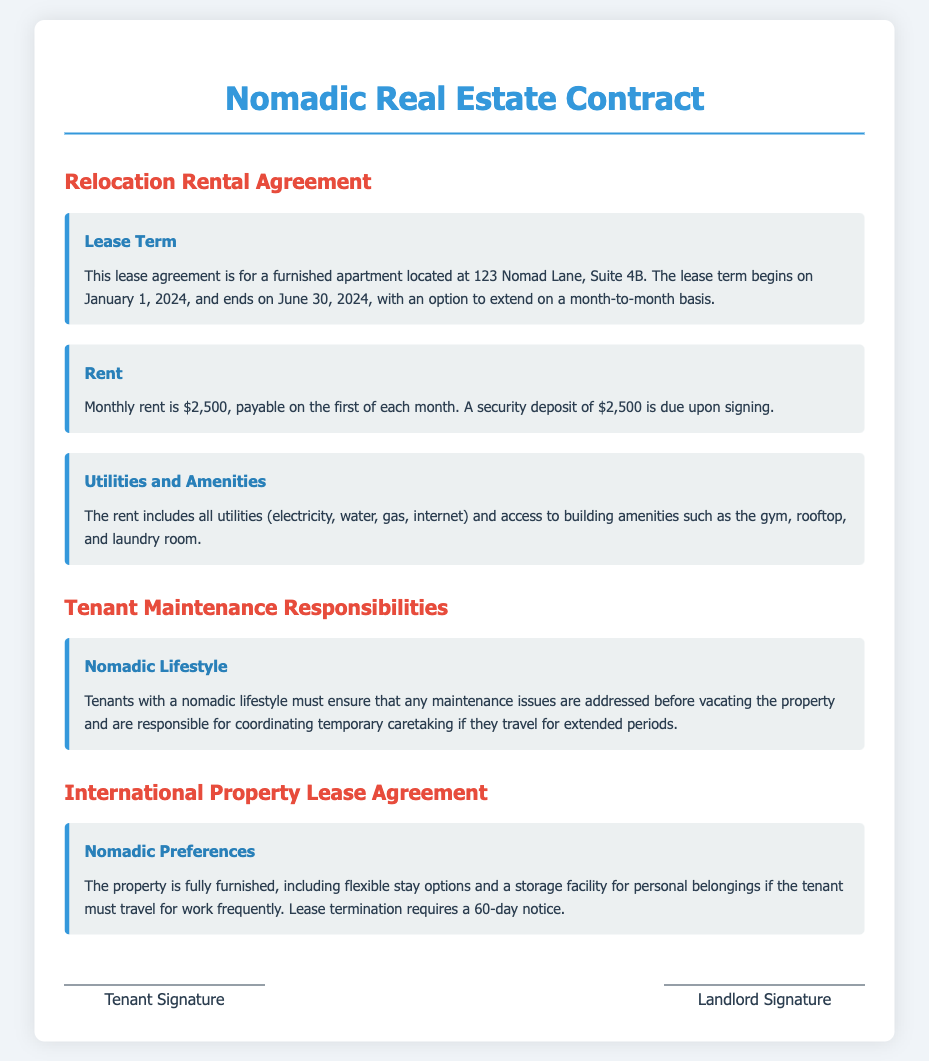What is the monthly rent for the apartment? The document states that the monthly rent for the apartment is $2,500.
Answer: $2,500 What is the lease term duration? The lease term begins on January 1, 2024, and ends on June 30, 2024.
Answer: January 1, 2024, to June 30, 2024 What is required upon signing the lease? A security deposit of $2,500 is due upon signing the lease agreement.
Answer: $2,500 What utilities are included in the rent? The rent includes electricity, water, gas, and internet.
Answer: All utilities What must tenants with a nomadic lifestyle do regarding maintenance? Tenants must ensure any maintenance issues are addressed before vacating the property.
Answer: Address maintenance issues What is the notice period for lease termination? Lease termination requires a notice period of 60 days according to the agreement.
Answer: 60 days What amenities are available to tenants? The amenities include a gym, rooftop, and laundry room as stated in the contract.
Answer: Gym, rooftop, laundry room What type of furniture is provided in the property? The property is fully furnished as mentioned in the international property lease agreement section.
Answer: Fully furnished What additional responsibility do nomadic tenants have? Nomadic tenants are responsible for coordinating temporary caretaking if they travel for extended periods.
Answer: Coordinate temporary caretaking 